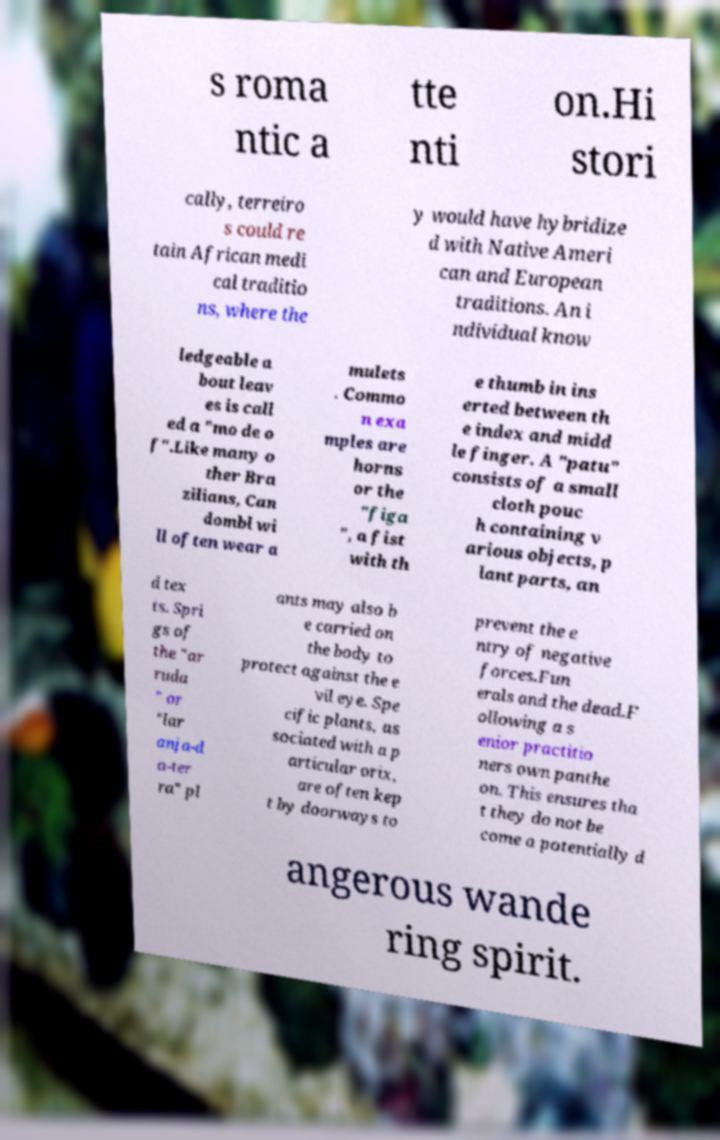What messages or text are displayed in this image? I need them in a readable, typed format. s roma ntic a tte nti on.Hi stori cally, terreiro s could re tain African medi cal traditio ns, where the y would have hybridize d with Native Ameri can and European traditions. An i ndividual know ledgeable a bout leav es is call ed a "mo de o f".Like many o ther Bra zilians, Can dombl wi ll often wear a mulets . Commo n exa mples are horns or the "figa ", a fist with th e thumb in ins erted between th e index and midd le finger. A "patu" consists of a small cloth pouc h containing v arious objects, p lant parts, an d tex ts. Spri gs of the "ar ruda " or "lar anja-d a-ter ra" pl ants may also b e carried on the body to protect against the e vil eye. Spe cific plants, as sociated with a p articular orix, are often kep t by doorways to prevent the e ntry of negative forces.Fun erals and the dead.F ollowing a s enior practitio ners own panthe on. This ensures tha t they do not be come a potentially d angerous wande ring spirit. 